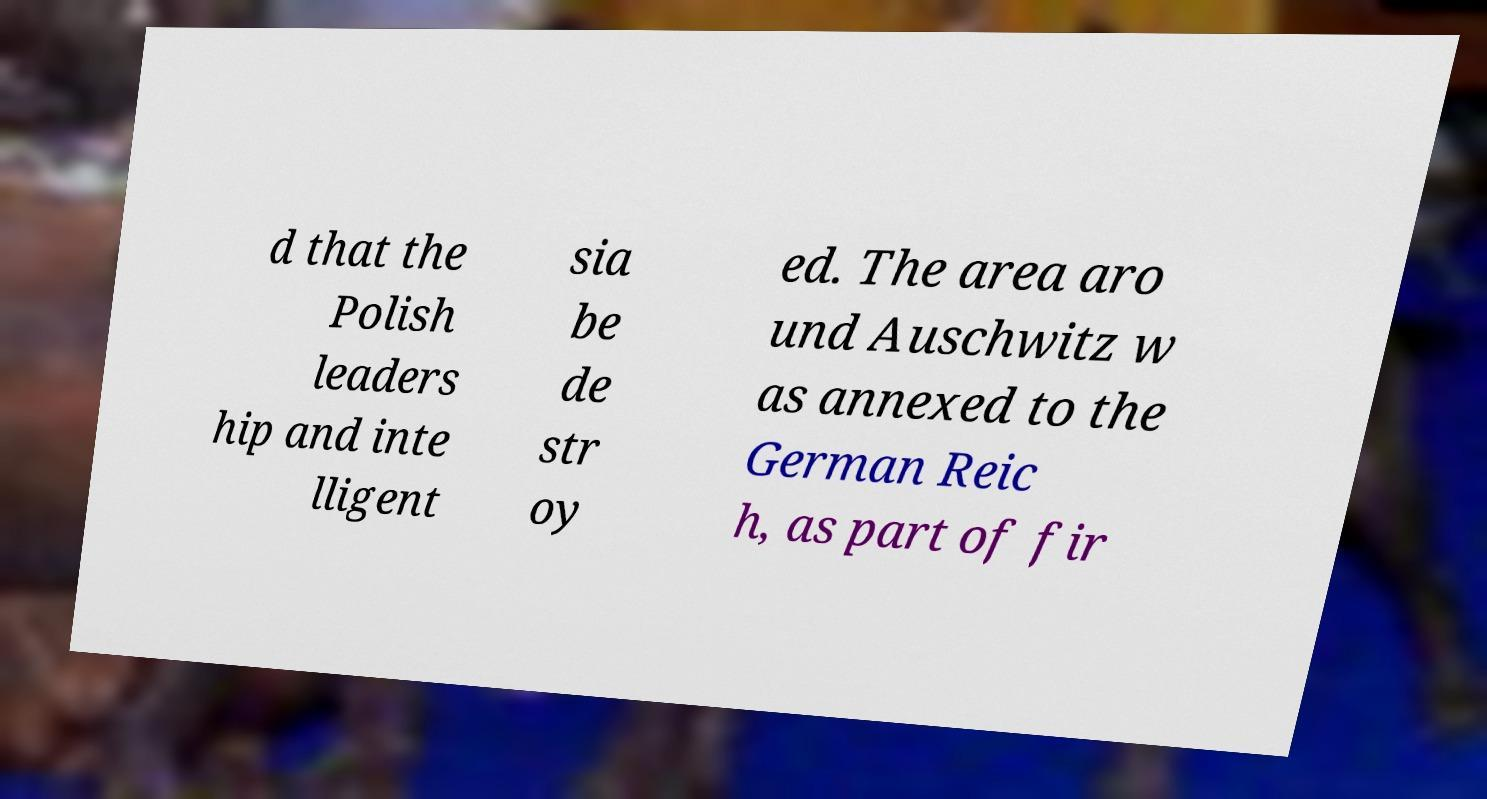Could you extract and type out the text from this image? d that the Polish leaders hip and inte lligent sia be de str oy ed. The area aro und Auschwitz w as annexed to the German Reic h, as part of fir 